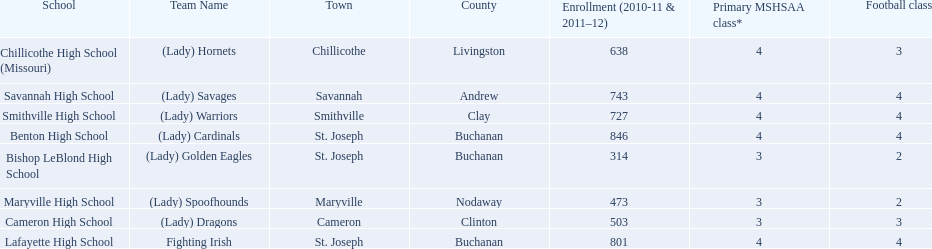Does lafayette high school or benton high school have green and grey as their colors? Lafayette High School. 